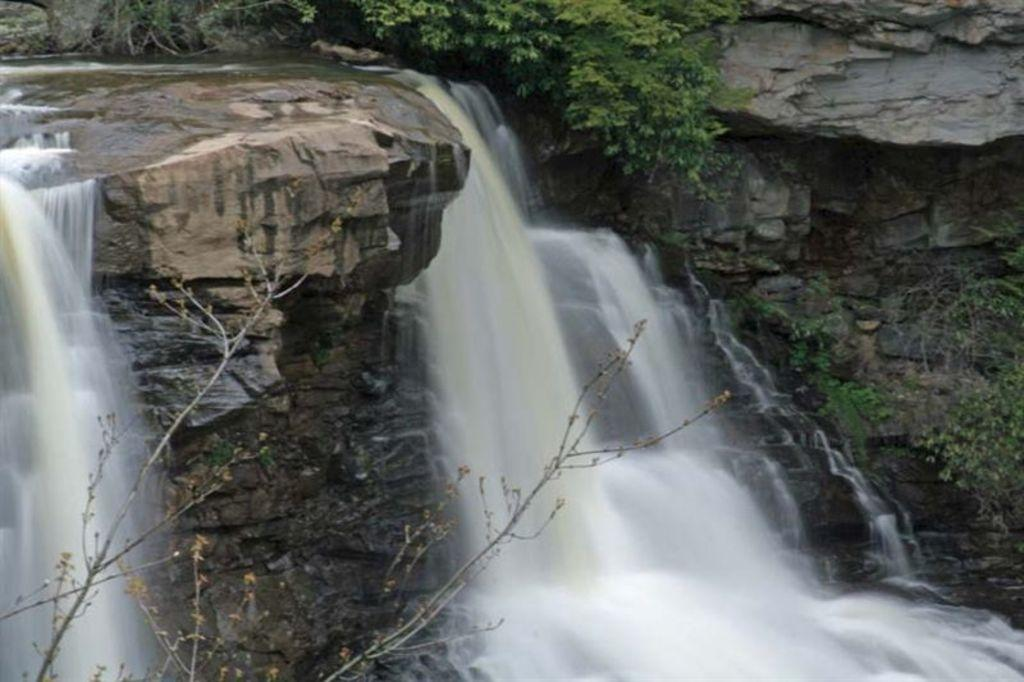What natural feature is present in the image? There is a waterfall in the image. What type of vegetation can be seen in the image? There are trees in the image. What type of glue is being used to hold the waterfall together in the image? There is no glue present in the image; it is a natural waterfall. Can you see any frogs hopping around near the waterfall in the image? There is no indication of any frogs present in the image. Is there any driving activity taking place in the image? There is no driving activity present in the image. 